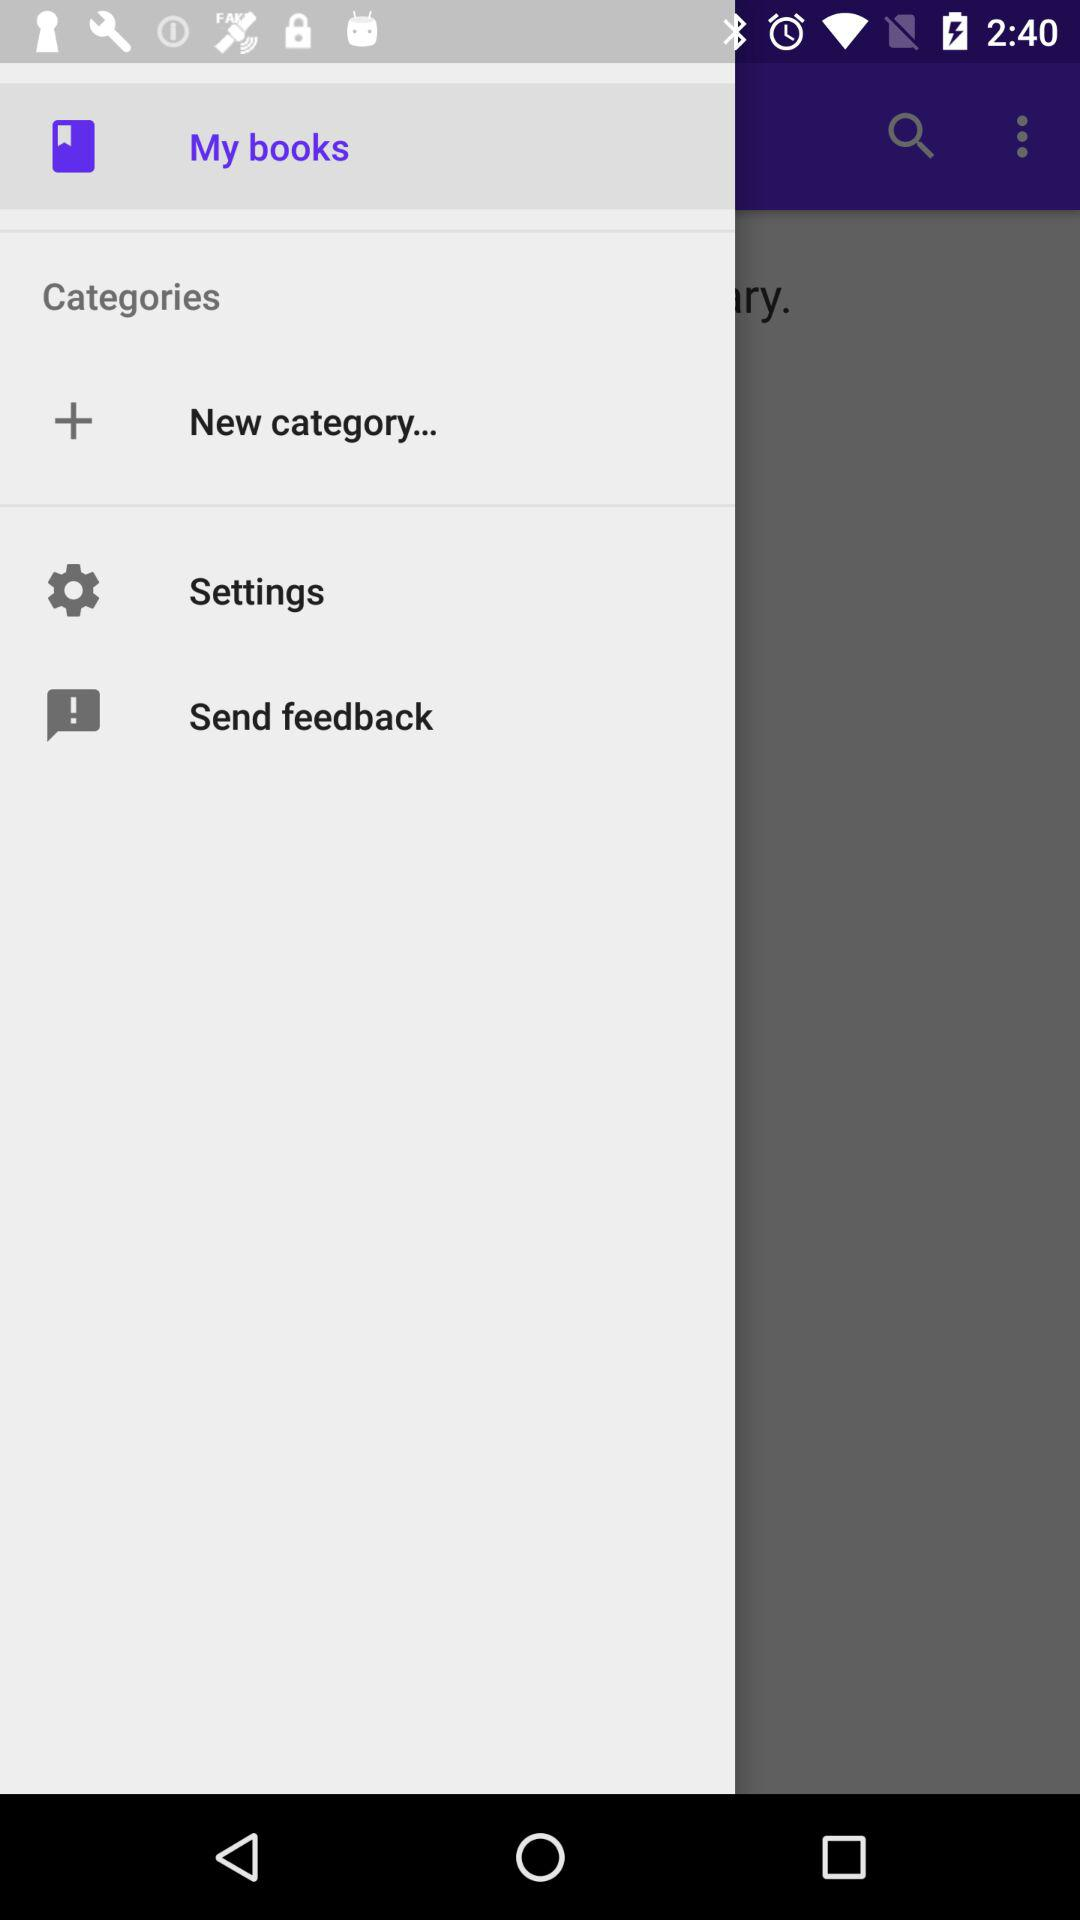Which option is selected? The selected option is "My books". 